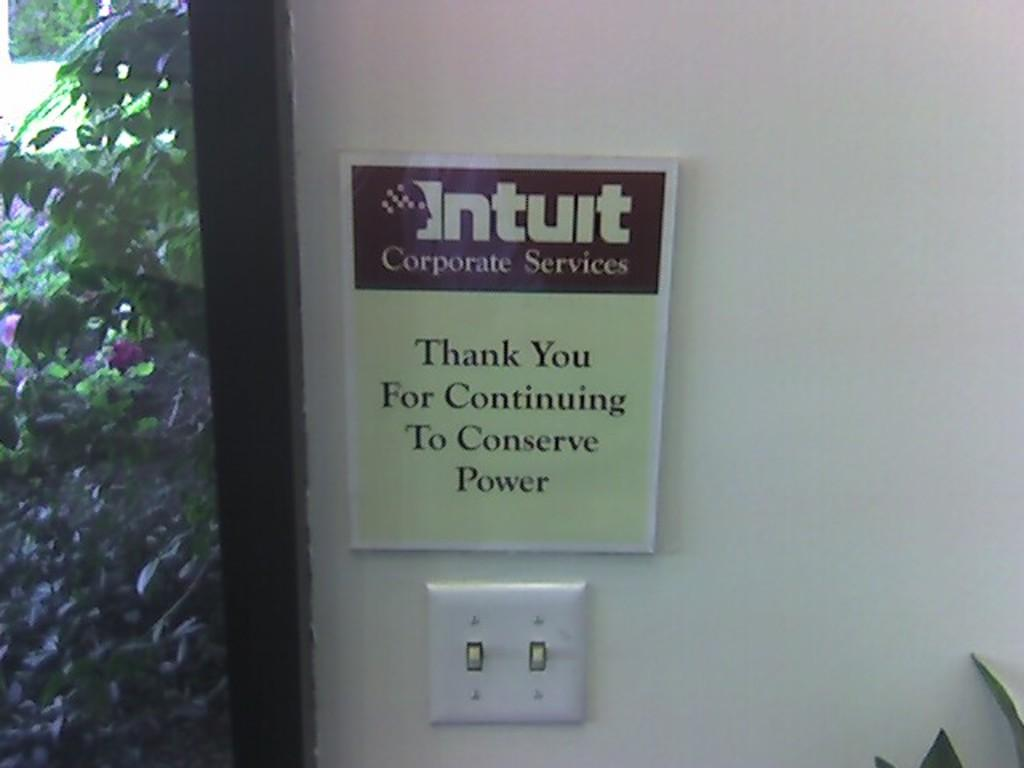What is attached to the white wall in the image? There is a board attached to the white wall in the image. What can be seen through the glass window in the image? The glass window in the image allows us to see trees. Can you describe the natural elements visible in the image? Trees are visible in the image. How does the cat kick the ball in the image? There is no cat or ball present in the image. What is the base of the board attached to the white wall in the image? The provided facts do not mention a base for the board; it is simply attached to the white wall. 